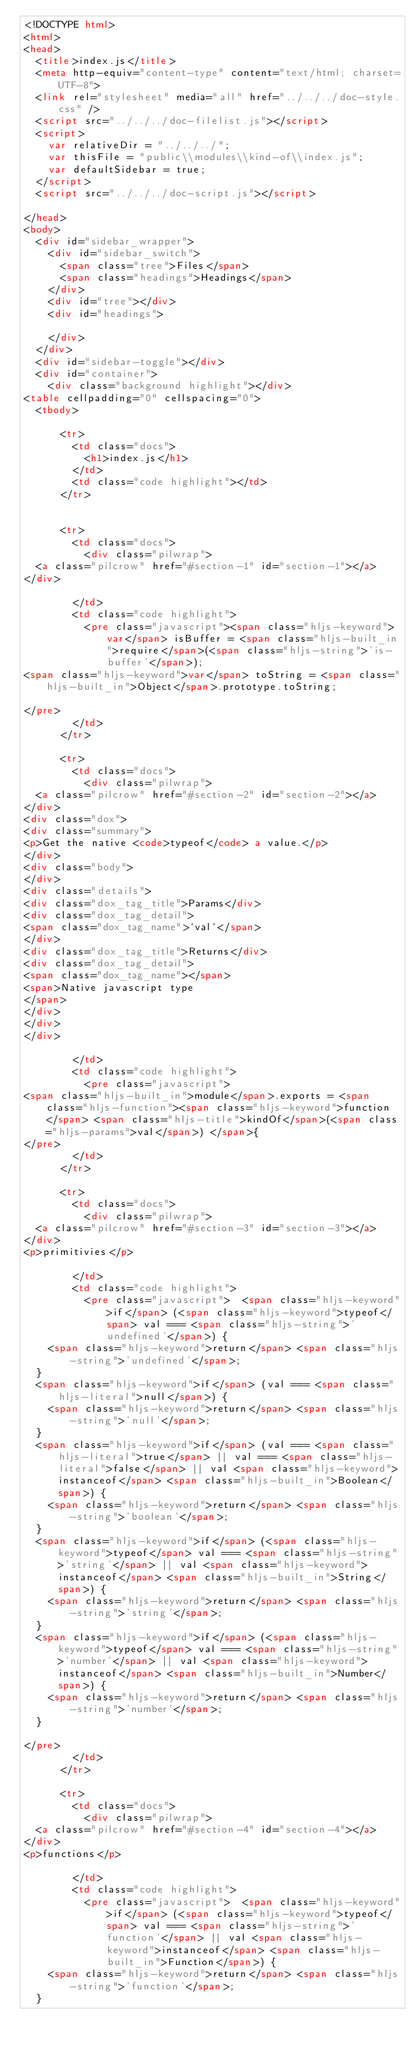Convert code to text. <code><loc_0><loc_0><loc_500><loc_500><_HTML_><!DOCTYPE html>
<html>
<head>
  <title>index.js</title>
  <meta http-equiv="content-type" content="text/html; charset=UTF-8">
  <link rel="stylesheet" media="all" href="../../../doc-style.css" />
  <script src="../../../doc-filelist.js"></script>
  <script>
    var relativeDir = "../../../";
    var thisFile = "public\\modules\\kind-of\\index.js";
    var defaultSidebar = true;
  </script>
  <script src="../../../doc-script.js"></script>

</head>
<body>
  <div id="sidebar_wrapper">
    <div id="sidebar_switch">
      <span class="tree">Files</span>
      <span class="headings">Headings</span>
    </div>
    <div id="tree"></div>
    <div id="headings">

    </div>
  </div>
  <div id="sidebar-toggle"></div>
  <div id="container">
    <div class="background highlight"></div>
<table cellpadding="0" cellspacing="0">
  <tbody>
    
      <tr>
        <td class="docs">
          <h1>index.js</h1>
        </td>
        <td class="code highlight"></td>
      </tr>
    
    
      <tr>
        <td class="docs">
          <div class="pilwrap">
  <a class="pilcrow" href="#section-1" id="section-1"></a>
</div>

        </td>
        <td class="code highlight">
          <pre class="javascript"><span class="hljs-keyword">var</span> isBuffer = <span class="hljs-built_in">require</span>(<span class="hljs-string">'is-buffer'</span>);
<span class="hljs-keyword">var</span> toString = <span class="hljs-built_in">Object</span>.prototype.toString;

</pre>
        </td>
      </tr>
    
      <tr>
        <td class="docs">
          <div class="pilwrap">
  <a class="pilcrow" href="#section-2" id="section-2"></a>
</div>
<div class="dox">
<div class="summary">
<p>Get the native <code>typeof</code> a value.</p>
</div>
<div class="body">
</div>
<div class="details">
<div class="dox_tag_title">Params</div>
<div class="dox_tag_detail">
<span class="dox_tag_name">`val`</span>
</div>
<div class="dox_tag_title">Returns</div>
<div class="dox_tag_detail">
<span class="dox_tag_name"></span>
<span>Native javascript type
</span>
</div>
</div>
</div>

        </td>
        <td class="code highlight">
          <pre class="javascript">
<span class="hljs-built_in">module</span>.exports = <span class="hljs-function"><span class="hljs-keyword">function</span> <span class="hljs-title">kindOf</span>(<span class="hljs-params">val</span>) </span>{
</pre>
        </td>
      </tr>
    
      <tr>
        <td class="docs">
          <div class="pilwrap">
  <a class="pilcrow" href="#section-3" id="section-3"></a>
</div>
<p>primitivies</p>

        </td>
        <td class="code highlight">
          <pre class="javascript">  <span class="hljs-keyword">if</span> (<span class="hljs-keyword">typeof</span> val === <span class="hljs-string">'undefined'</span>) {
    <span class="hljs-keyword">return</span> <span class="hljs-string">'undefined'</span>;
  }
  <span class="hljs-keyword">if</span> (val === <span class="hljs-literal">null</span>) {
    <span class="hljs-keyword">return</span> <span class="hljs-string">'null'</span>;
  }
  <span class="hljs-keyword">if</span> (val === <span class="hljs-literal">true</span> || val === <span class="hljs-literal">false</span> || val <span class="hljs-keyword">instanceof</span> <span class="hljs-built_in">Boolean</span>) {
    <span class="hljs-keyword">return</span> <span class="hljs-string">'boolean'</span>;
  }
  <span class="hljs-keyword">if</span> (<span class="hljs-keyword">typeof</span> val === <span class="hljs-string">'string'</span> || val <span class="hljs-keyword">instanceof</span> <span class="hljs-built_in">String</span>) {
    <span class="hljs-keyword">return</span> <span class="hljs-string">'string'</span>;
  }
  <span class="hljs-keyword">if</span> (<span class="hljs-keyword">typeof</span> val === <span class="hljs-string">'number'</span> || val <span class="hljs-keyword">instanceof</span> <span class="hljs-built_in">Number</span>) {
    <span class="hljs-keyword">return</span> <span class="hljs-string">'number'</span>;
  }

</pre>
        </td>
      </tr>
    
      <tr>
        <td class="docs">
          <div class="pilwrap">
  <a class="pilcrow" href="#section-4" id="section-4"></a>
</div>
<p>functions</p>

        </td>
        <td class="code highlight">
          <pre class="javascript">  <span class="hljs-keyword">if</span> (<span class="hljs-keyword">typeof</span> val === <span class="hljs-string">'function'</span> || val <span class="hljs-keyword">instanceof</span> <span class="hljs-built_in">Function</span>) {
    <span class="hljs-keyword">return</span> <span class="hljs-string">'function'</span>;
  }
</code> 